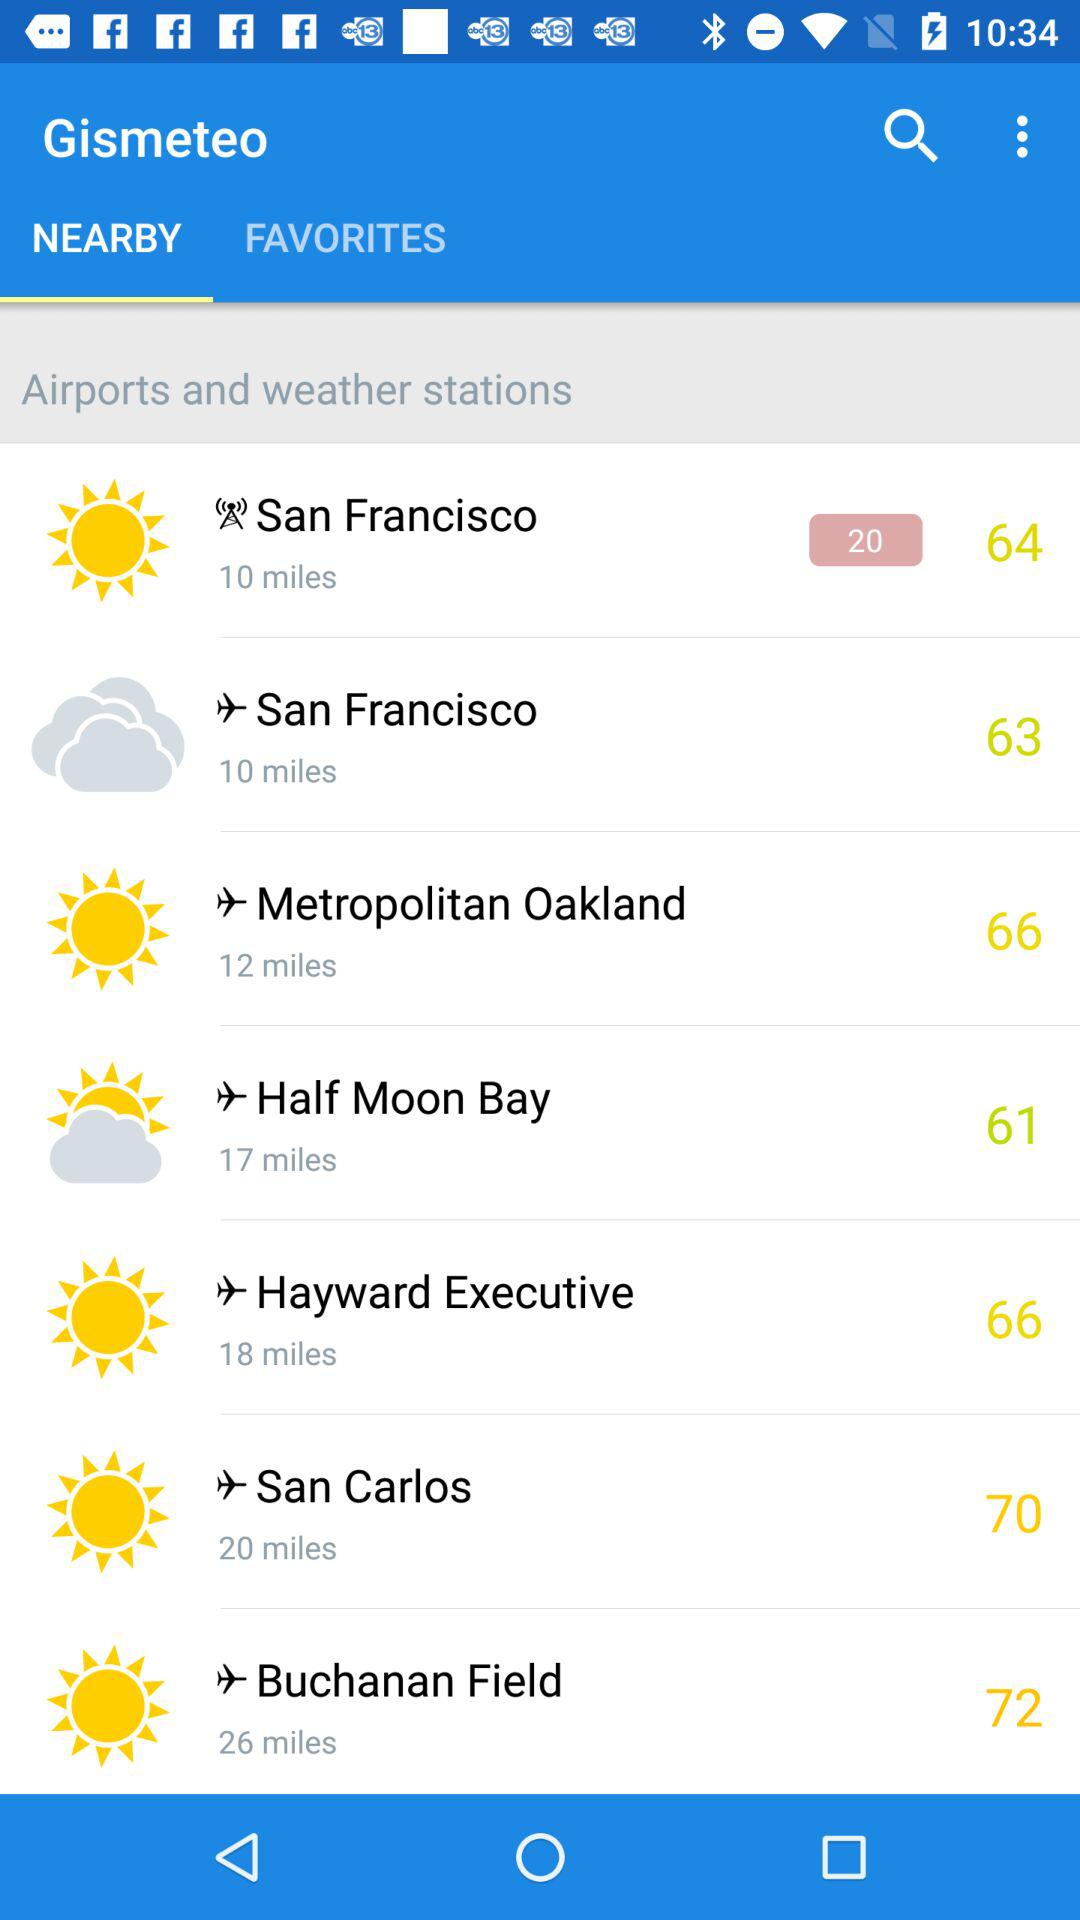How many miles farther is San Francisco to Buchanan Field than it is to Metropolitan Oakland?
Answer the question using a single word or phrase. 14 